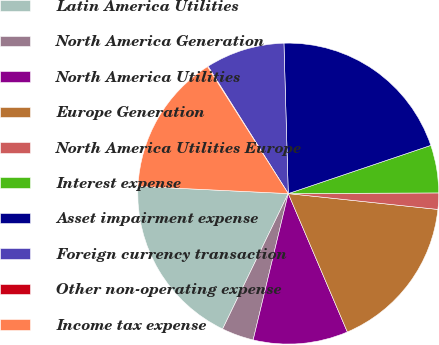Convert chart. <chart><loc_0><loc_0><loc_500><loc_500><pie_chart><fcel>Latin America Utilities<fcel>North America Generation<fcel>North America Utilities<fcel>Europe Generation<fcel>North America Utilities Europe<fcel>Interest expense<fcel>Asset impairment expense<fcel>Foreign currency transaction<fcel>Other non-operating expense<fcel>Income tax expense<nl><fcel>18.58%<fcel>3.44%<fcel>10.17%<fcel>16.9%<fcel>1.75%<fcel>5.12%<fcel>20.27%<fcel>8.49%<fcel>0.07%<fcel>15.22%<nl></chart> 